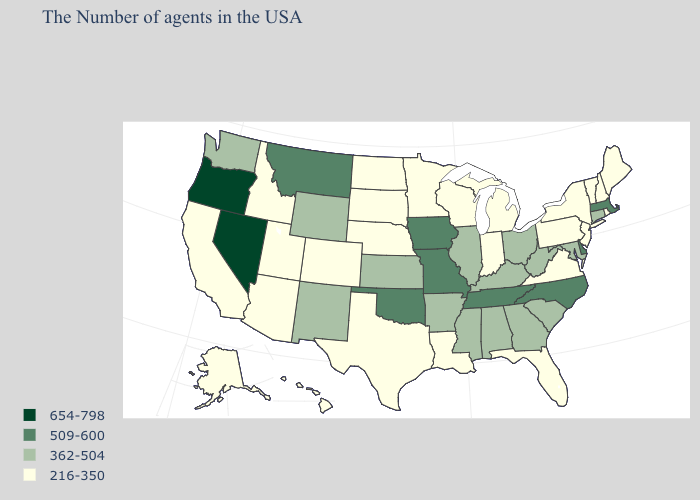What is the value of Nevada?
Short answer required. 654-798. Name the states that have a value in the range 509-600?
Concise answer only. Massachusetts, Delaware, North Carolina, Tennessee, Missouri, Iowa, Oklahoma, Montana. Does Minnesota have the lowest value in the USA?
Concise answer only. Yes. Does the map have missing data?
Keep it brief. No. Name the states that have a value in the range 509-600?
Short answer required. Massachusetts, Delaware, North Carolina, Tennessee, Missouri, Iowa, Oklahoma, Montana. Name the states that have a value in the range 654-798?
Concise answer only. Nevada, Oregon. What is the lowest value in the USA?
Concise answer only. 216-350. Which states have the lowest value in the MidWest?
Short answer required. Michigan, Indiana, Wisconsin, Minnesota, Nebraska, South Dakota, North Dakota. Does Texas have the lowest value in the South?
Quick response, please. Yes. Does Oregon have the highest value in the USA?
Answer briefly. Yes. Does the first symbol in the legend represent the smallest category?
Short answer required. No. What is the value of Nebraska?
Short answer required. 216-350. Name the states that have a value in the range 509-600?
Be succinct. Massachusetts, Delaware, North Carolina, Tennessee, Missouri, Iowa, Oklahoma, Montana. Does Wyoming have the lowest value in the West?
Concise answer only. No. Name the states that have a value in the range 654-798?
Answer briefly. Nevada, Oregon. 